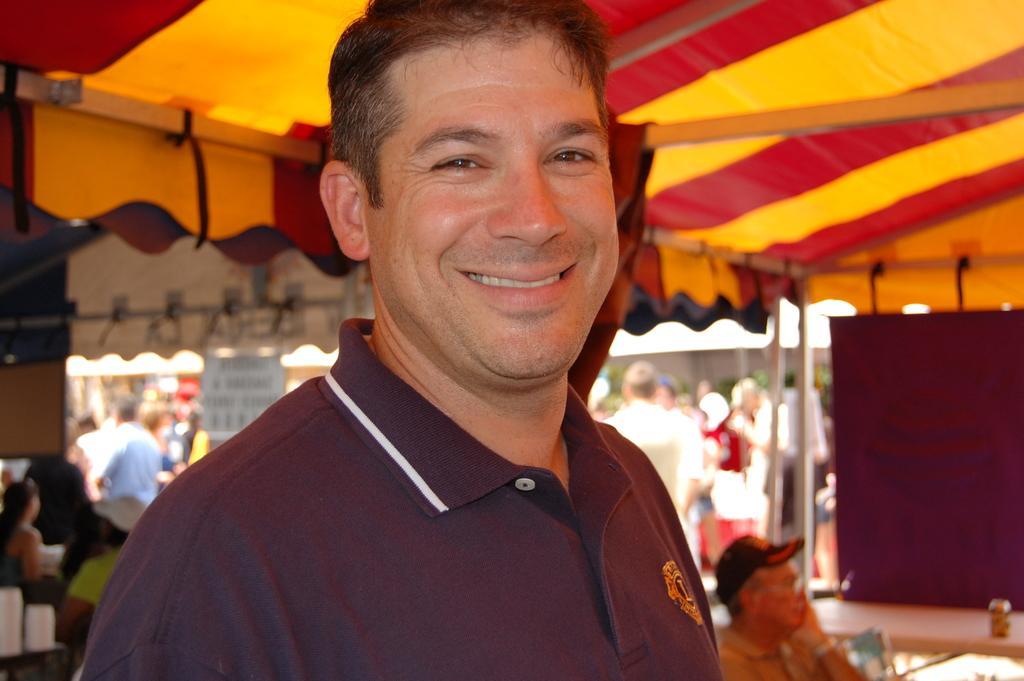Please provide a concise description of this image. In the image a man is standing and smiling. Behind him few people are standing and sitting and there are some tents. 